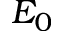<formula> <loc_0><loc_0><loc_500><loc_500>E _ { 0 }</formula> 